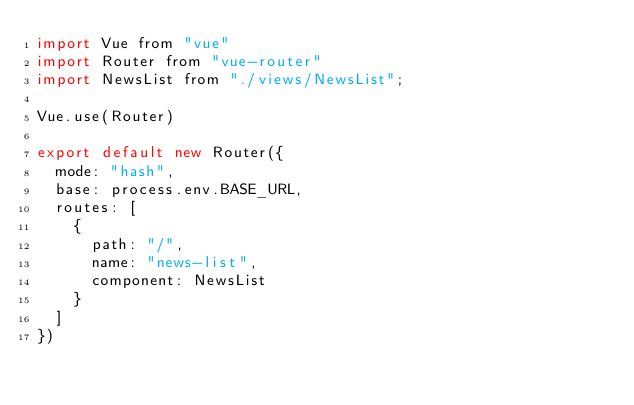<code> <loc_0><loc_0><loc_500><loc_500><_JavaScript_>import Vue from "vue"
import Router from "vue-router"
import NewsList from "./views/NewsList";

Vue.use(Router)

export default new Router({
  mode: "hash",
  base: process.env.BASE_URL,
  routes: [
    {
      path: "/",
      name: "news-list",
      component: NewsList
    }
  ]
})
</code> 